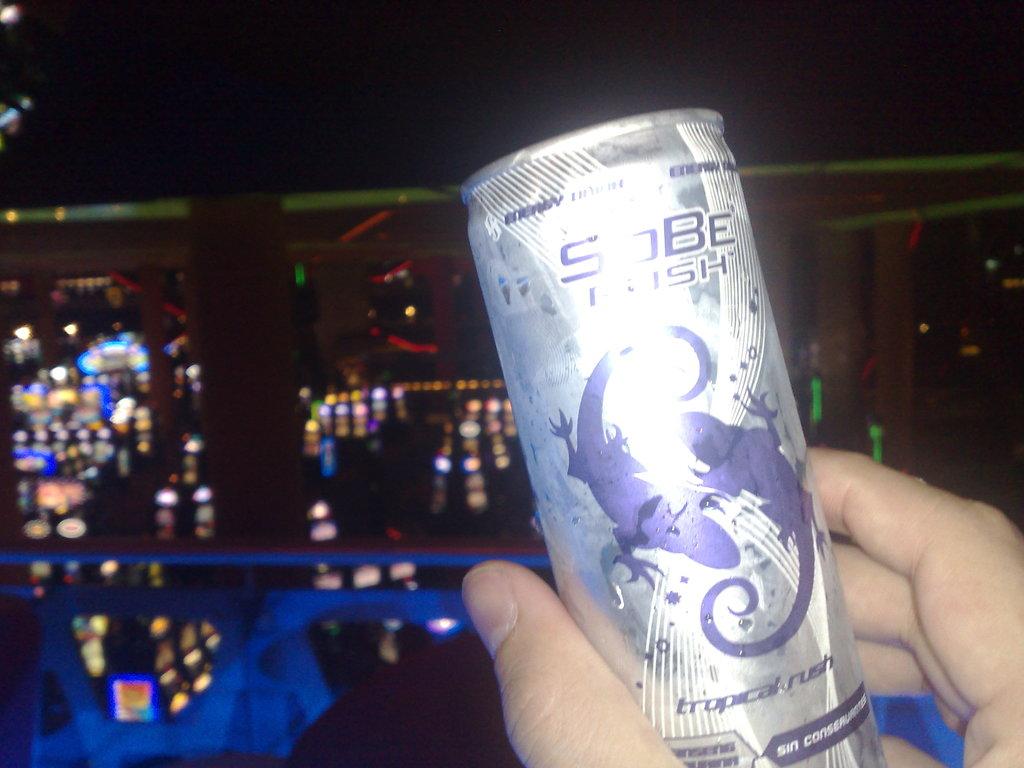What does the can say?
Ensure brevity in your answer.  Tropical rush. 